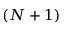Convert formula to latex. <formula><loc_0><loc_0><loc_500><loc_500>( N + 1 )</formula> 